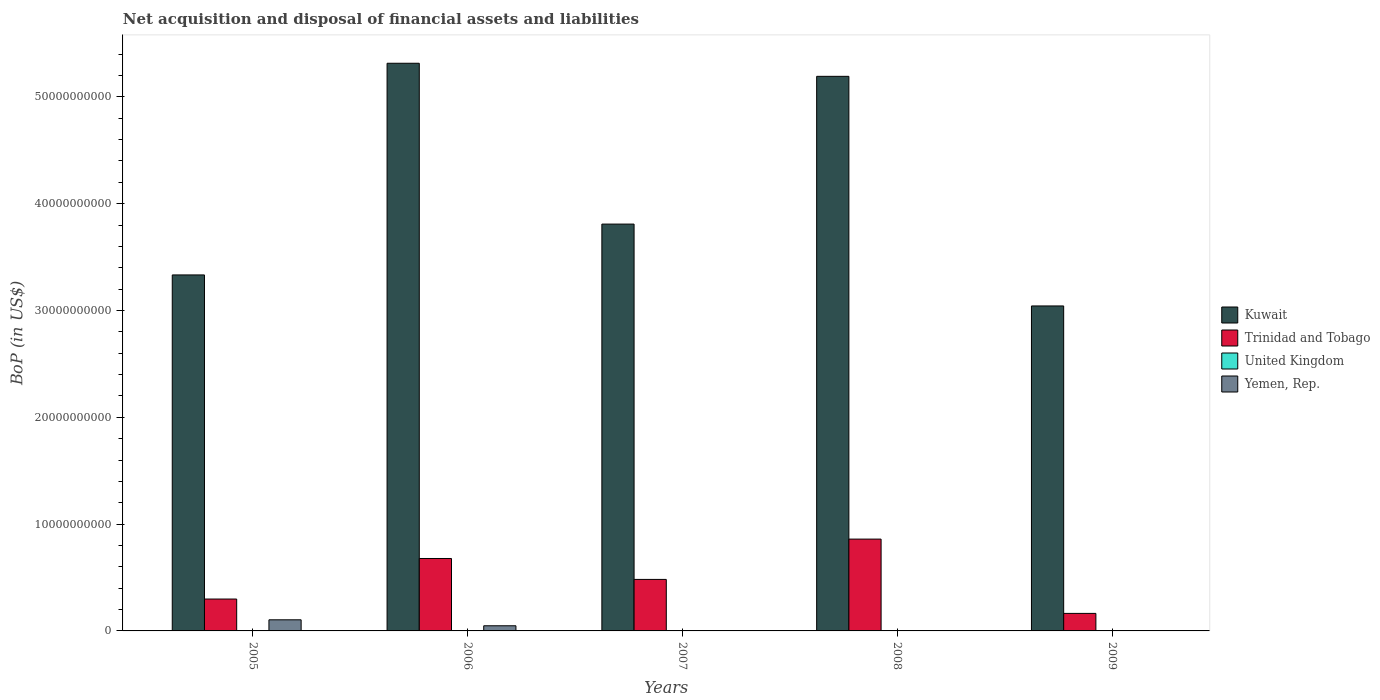How many different coloured bars are there?
Your answer should be very brief. 3. How many groups of bars are there?
Provide a short and direct response. 5. How many bars are there on the 3rd tick from the left?
Offer a very short reply. 2. How many bars are there on the 1st tick from the right?
Provide a short and direct response. 2. What is the label of the 3rd group of bars from the left?
Your response must be concise. 2007. In how many cases, is the number of bars for a given year not equal to the number of legend labels?
Ensure brevity in your answer.  5. What is the Balance of Payments in Trinidad and Tobago in 2007?
Your answer should be very brief. 4.82e+09. Across all years, what is the maximum Balance of Payments in Yemen, Rep.?
Provide a short and direct response. 1.04e+09. Across all years, what is the minimum Balance of Payments in United Kingdom?
Your answer should be very brief. 0. In which year was the Balance of Payments in Trinidad and Tobago maximum?
Your answer should be compact. 2008. What is the total Balance of Payments in Yemen, Rep. in the graph?
Keep it short and to the point. 1.52e+09. What is the difference between the Balance of Payments in Kuwait in 2006 and that in 2007?
Keep it short and to the point. 1.51e+1. What is the difference between the Balance of Payments in Trinidad and Tobago in 2009 and the Balance of Payments in Yemen, Rep. in 2006?
Make the answer very short. 1.16e+09. What is the average Balance of Payments in Trinidad and Tobago per year?
Keep it short and to the point. 4.96e+09. In the year 2006, what is the difference between the Balance of Payments in Kuwait and Balance of Payments in Yemen, Rep.?
Provide a succinct answer. 5.27e+1. In how many years, is the Balance of Payments in Yemen, Rep. greater than 50000000000 US$?
Keep it short and to the point. 0. Is the Balance of Payments in Trinidad and Tobago in 2006 less than that in 2008?
Make the answer very short. Yes. What is the difference between the highest and the second highest Balance of Payments in Kuwait?
Your response must be concise. 1.22e+09. What is the difference between the highest and the lowest Balance of Payments in Kuwait?
Offer a terse response. 2.27e+1. Is it the case that in every year, the sum of the Balance of Payments in Kuwait and Balance of Payments in United Kingdom is greater than the sum of Balance of Payments in Trinidad and Tobago and Balance of Payments in Yemen, Rep.?
Ensure brevity in your answer.  Yes. How many bars are there?
Your answer should be compact. 12. Are all the bars in the graph horizontal?
Offer a terse response. No. How many years are there in the graph?
Your answer should be compact. 5. What is the difference between two consecutive major ticks on the Y-axis?
Your response must be concise. 1.00e+1. Are the values on the major ticks of Y-axis written in scientific E-notation?
Your answer should be very brief. No. Does the graph contain grids?
Keep it short and to the point. No. How many legend labels are there?
Ensure brevity in your answer.  4. What is the title of the graph?
Provide a succinct answer. Net acquisition and disposal of financial assets and liabilities. Does "Guyana" appear as one of the legend labels in the graph?
Keep it short and to the point. No. What is the label or title of the Y-axis?
Give a very brief answer. BoP (in US$). What is the BoP (in US$) of Kuwait in 2005?
Your answer should be very brief. 3.33e+1. What is the BoP (in US$) in Trinidad and Tobago in 2005?
Give a very brief answer. 2.98e+09. What is the BoP (in US$) in Yemen, Rep. in 2005?
Offer a very short reply. 1.04e+09. What is the BoP (in US$) of Kuwait in 2006?
Offer a terse response. 5.31e+1. What is the BoP (in US$) in Trinidad and Tobago in 2006?
Make the answer very short. 6.78e+09. What is the BoP (in US$) in United Kingdom in 2006?
Your answer should be compact. 0. What is the BoP (in US$) of Yemen, Rep. in 2006?
Make the answer very short. 4.81e+08. What is the BoP (in US$) in Kuwait in 2007?
Your response must be concise. 3.81e+1. What is the BoP (in US$) in Trinidad and Tobago in 2007?
Provide a succinct answer. 4.82e+09. What is the BoP (in US$) of Yemen, Rep. in 2007?
Keep it short and to the point. 0. What is the BoP (in US$) in Kuwait in 2008?
Provide a short and direct response. 5.19e+1. What is the BoP (in US$) in Trinidad and Tobago in 2008?
Provide a succinct answer. 8.60e+09. What is the BoP (in US$) of United Kingdom in 2008?
Your response must be concise. 0. What is the BoP (in US$) in Yemen, Rep. in 2008?
Ensure brevity in your answer.  0. What is the BoP (in US$) in Kuwait in 2009?
Make the answer very short. 3.04e+1. What is the BoP (in US$) of Trinidad and Tobago in 2009?
Provide a succinct answer. 1.64e+09. What is the BoP (in US$) in United Kingdom in 2009?
Make the answer very short. 0. What is the BoP (in US$) of Yemen, Rep. in 2009?
Give a very brief answer. 0. Across all years, what is the maximum BoP (in US$) of Kuwait?
Offer a terse response. 5.31e+1. Across all years, what is the maximum BoP (in US$) in Trinidad and Tobago?
Offer a terse response. 8.60e+09. Across all years, what is the maximum BoP (in US$) in Yemen, Rep.?
Provide a short and direct response. 1.04e+09. Across all years, what is the minimum BoP (in US$) of Kuwait?
Offer a very short reply. 3.04e+1. Across all years, what is the minimum BoP (in US$) of Trinidad and Tobago?
Provide a succinct answer. 1.64e+09. Across all years, what is the minimum BoP (in US$) in Yemen, Rep.?
Offer a terse response. 0. What is the total BoP (in US$) of Kuwait in the graph?
Give a very brief answer. 2.07e+11. What is the total BoP (in US$) of Trinidad and Tobago in the graph?
Provide a short and direct response. 2.48e+1. What is the total BoP (in US$) of United Kingdom in the graph?
Ensure brevity in your answer.  0. What is the total BoP (in US$) of Yemen, Rep. in the graph?
Your answer should be very brief. 1.52e+09. What is the difference between the BoP (in US$) in Kuwait in 2005 and that in 2006?
Offer a very short reply. -1.98e+1. What is the difference between the BoP (in US$) of Trinidad and Tobago in 2005 and that in 2006?
Your answer should be compact. -3.80e+09. What is the difference between the BoP (in US$) in Yemen, Rep. in 2005 and that in 2006?
Your answer should be compact. 5.59e+08. What is the difference between the BoP (in US$) of Kuwait in 2005 and that in 2007?
Offer a terse response. -4.76e+09. What is the difference between the BoP (in US$) in Trinidad and Tobago in 2005 and that in 2007?
Your answer should be compact. -1.84e+09. What is the difference between the BoP (in US$) in Kuwait in 2005 and that in 2008?
Keep it short and to the point. -1.86e+1. What is the difference between the BoP (in US$) of Trinidad and Tobago in 2005 and that in 2008?
Offer a very short reply. -5.61e+09. What is the difference between the BoP (in US$) of Kuwait in 2005 and that in 2009?
Your response must be concise. 2.90e+09. What is the difference between the BoP (in US$) of Trinidad and Tobago in 2005 and that in 2009?
Offer a terse response. 1.34e+09. What is the difference between the BoP (in US$) in Kuwait in 2006 and that in 2007?
Offer a terse response. 1.51e+1. What is the difference between the BoP (in US$) in Trinidad and Tobago in 2006 and that in 2007?
Your answer should be compact. 1.96e+09. What is the difference between the BoP (in US$) in Kuwait in 2006 and that in 2008?
Your answer should be compact. 1.22e+09. What is the difference between the BoP (in US$) of Trinidad and Tobago in 2006 and that in 2008?
Make the answer very short. -1.82e+09. What is the difference between the BoP (in US$) of Kuwait in 2006 and that in 2009?
Offer a terse response. 2.27e+1. What is the difference between the BoP (in US$) in Trinidad and Tobago in 2006 and that in 2009?
Provide a short and direct response. 5.14e+09. What is the difference between the BoP (in US$) in Kuwait in 2007 and that in 2008?
Your answer should be compact. -1.38e+1. What is the difference between the BoP (in US$) in Trinidad and Tobago in 2007 and that in 2008?
Provide a succinct answer. -3.77e+09. What is the difference between the BoP (in US$) in Kuwait in 2007 and that in 2009?
Provide a short and direct response. 7.66e+09. What is the difference between the BoP (in US$) in Trinidad and Tobago in 2007 and that in 2009?
Give a very brief answer. 3.18e+09. What is the difference between the BoP (in US$) of Kuwait in 2008 and that in 2009?
Provide a succinct answer. 2.15e+1. What is the difference between the BoP (in US$) in Trinidad and Tobago in 2008 and that in 2009?
Ensure brevity in your answer.  6.96e+09. What is the difference between the BoP (in US$) of Kuwait in 2005 and the BoP (in US$) of Trinidad and Tobago in 2006?
Your answer should be very brief. 2.65e+1. What is the difference between the BoP (in US$) of Kuwait in 2005 and the BoP (in US$) of Yemen, Rep. in 2006?
Offer a very short reply. 3.28e+1. What is the difference between the BoP (in US$) of Trinidad and Tobago in 2005 and the BoP (in US$) of Yemen, Rep. in 2006?
Give a very brief answer. 2.50e+09. What is the difference between the BoP (in US$) of Kuwait in 2005 and the BoP (in US$) of Trinidad and Tobago in 2007?
Offer a very short reply. 2.85e+1. What is the difference between the BoP (in US$) in Kuwait in 2005 and the BoP (in US$) in Trinidad and Tobago in 2008?
Your answer should be very brief. 2.47e+1. What is the difference between the BoP (in US$) in Kuwait in 2005 and the BoP (in US$) in Trinidad and Tobago in 2009?
Provide a succinct answer. 3.17e+1. What is the difference between the BoP (in US$) in Kuwait in 2006 and the BoP (in US$) in Trinidad and Tobago in 2007?
Offer a terse response. 4.83e+1. What is the difference between the BoP (in US$) in Kuwait in 2006 and the BoP (in US$) in Trinidad and Tobago in 2008?
Keep it short and to the point. 4.45e+1. What is the difference between the BoP (in US$) in Kuwait in 2006 and the BoP (in US$) in Trinidad and Tobago in 2009?
Offer a terse response. 5.15e+1. What is the difference between the BoP (in US$) of Kuwait in 2007 and the BoP (in US$) of Trinidad and Tobago in 2008?
Offer a terse response. 2.95e+1. What is the difference between the BoP (in US$) in Kuwait in 2007 and the BoP (in US$) in Trinidad and Tobago in 2009?
Ensure brevity in your answer.  3.64e+1. What is the difference between the BoP (in US$) of Kuwait in 2008 and the BoP (in US$) of Trinidad and Tobago in 2009?
Make the answer very short. 5.03e+1. What is the average BoP (in US$) of Kuwait per year?
Your answer should be compact. 4.14e+1. What is the average BoP (in US$) of Trinidad and Tobago per year?
Provide a succinct answer. 4.96e+09. What is the average BoP (in US$) in Yemen, Rep. per year?
Ensure brevity in your answer.  3.04e+08. In the year 2005, what is the difference between the BoP (in US$) of Kuwait and BoP (in US$) of Trinidad and Tobago?
Make the answer very short. 3.03e+1. In the year 2005, what is the difference between the BoP (in US$) in Kuwait and BoP (in US$) in Yemen, Rep.?
Provide a short and direct response. 3.23e+1. In the year 2005, what is the difference between the BoP (in US$) in Trinidad and Tobago and BoP (in US$) in Yemen, Rep.?
Provide a short and direct response. 1.94e+09. In the year 2006, what is the difference between the BoP (in US$) in Kuwait and BoP (in US$) in Trinidad and Tobago?
Your answer should be compact. 4.64e+1. In the year 2006, what is the difference between the BoP (in US$) of Kuwait and BoP (in US$) of Yemen, Rep.?
Your response must be concise. 5.27e+1. In the year 2006, what is the difference between the BoP (in US$) of Trinidad and Tobago and BoP (in US$) of Yemen, Rep.?
Ensure brevity in your answer.  6.30e+09. In the year 2007, what is the difference between the BoP (in US$) of Kuwait and BoP (in US$) of Trinidad and Tobago?
Your answer should be very brief. 3.33e+1. In the year 2008, what is the difference between the BoP (in US$) in Kuwait and BoP (in US$) in Trinidad and Tobago?
Ensure brevity in your answer.  4.33e+1. In the year 2009, what is the difference between the BoP (in US$) of Kuwait and BoP (in US$) of Trinidad and Tobago?
Offer a very short reply. 2.88e+1. What is the ratio of the BoP (in US$) of Kuwait in 2005 to that in 2006?
Keep it short and to the point. 0.63. What is the ratio of the BoP (in US$) in Trinidad and Tobago in 2005 to that in 2006?
Your response must be concise. 0.44. What is the ratio of the BoP (in US$) of Yemen, Rep. in 2005 to that in 2006?
Give a very brief answer. 2.16. What is the ratio of the BoP (in US$) of Kuwait in 2005 to that in 2007?
Keep it short and to the point. 0.88. What is the ratio of the BoP (in US$) of Trinidad and Tobago in 2005 to that in 2007?
Offer a very short reply. 0.62. What is the ratio of the BoP (in US$) of Kuwait in 2005 to that in 2008?
Make the answer very short. 0.64. What is the ratio of the BoP (in US$) in Trinidad and Tobago in 2005 to that in 2008?
Give a very brief answer. 0.35. What is the ratio of the BoP (in US$) in Kuwait in 2005 to that in 2009?
Offer a very short reply. 1.1. What is the ratio of the BoP (in US$) in Trinidad and Tobago in 2005 to that in 2009?
Your answer should be compact. 1.82. What is the ratio of the BoP (in US$) of Kuwait in 2006 to that in 2007?
Make the answer very short. 1.4. What is the ratio of the BoP (in US$) of Trinidad and Tobago in 2006 to that in 2007?
Ensure brevity in your answer.  1.41. What is the ratio of the BoP (in US$) of Kuwait in 2006 to that in 2008?
Provide a succinct answer. 1.02. What is the ratio of the BoP (in US$) of Trinidad and Tobago in 2006 to that in 2008?
Your answer should be very brief. 0.79. What is the ratio of the BoP (in US$) in Kuwait in 2006 to that in 2009?
Offer a terse response. 1.75. What is the ratio of the BoP (in US$) in Trinidad and Tobago in 2006 to that in 2009?
Make the answer very short. 4.13. What is the ratio of the BoP (in US$) of Kuwait in 2007 to that in 2008?
Provide a short and direct response. 0.73. What is the ratio of the BoP (in US$) in Trinidad and Tobago in 2007 to that in 2008?
Your response must be concise. 0.56. What is the ratio of the BoP (in US$) in Kuwait in 2007 to that in 2009?
Give a very brief answer. 1.25. What is the ratio of the BoP (in US$) of Trinidad and Tobago in 2007 to that in 2009?
Keep it short and to the point. 2.94. What is the ratio of the BoP (in US$) in Kuwait in 2008 to that in 2009?
Offer a very short reply. 1.71. What is the ratio of the BoP (in US$) in Trinidad and Tobago in 2008 to that in 2009?
Offer a very short reply. 5.24. What is the difference between the highest and the second highest BoP (in US$) in Kuwait?
Make the answer very short. 1.22e+09. What is the difference between the highest and the second highest BoP (in US$) in Trinidad and Tobago?
Offer a very short reply. 1.82e+09. What is the difference between the highest and the lowest BoP (in US$) in Kuwait?
Give a very brief answer. 2.27e+1. What is the difference between the highest and the lowest BoP (in US$) in Trinidad and Tobago?
Provide a short and direct response. 6.96e+09. What is the difference between the highest and the lowest BoP (in US$) of Yemen, Rep.?
Offer a terse response. 1.04e+09. 